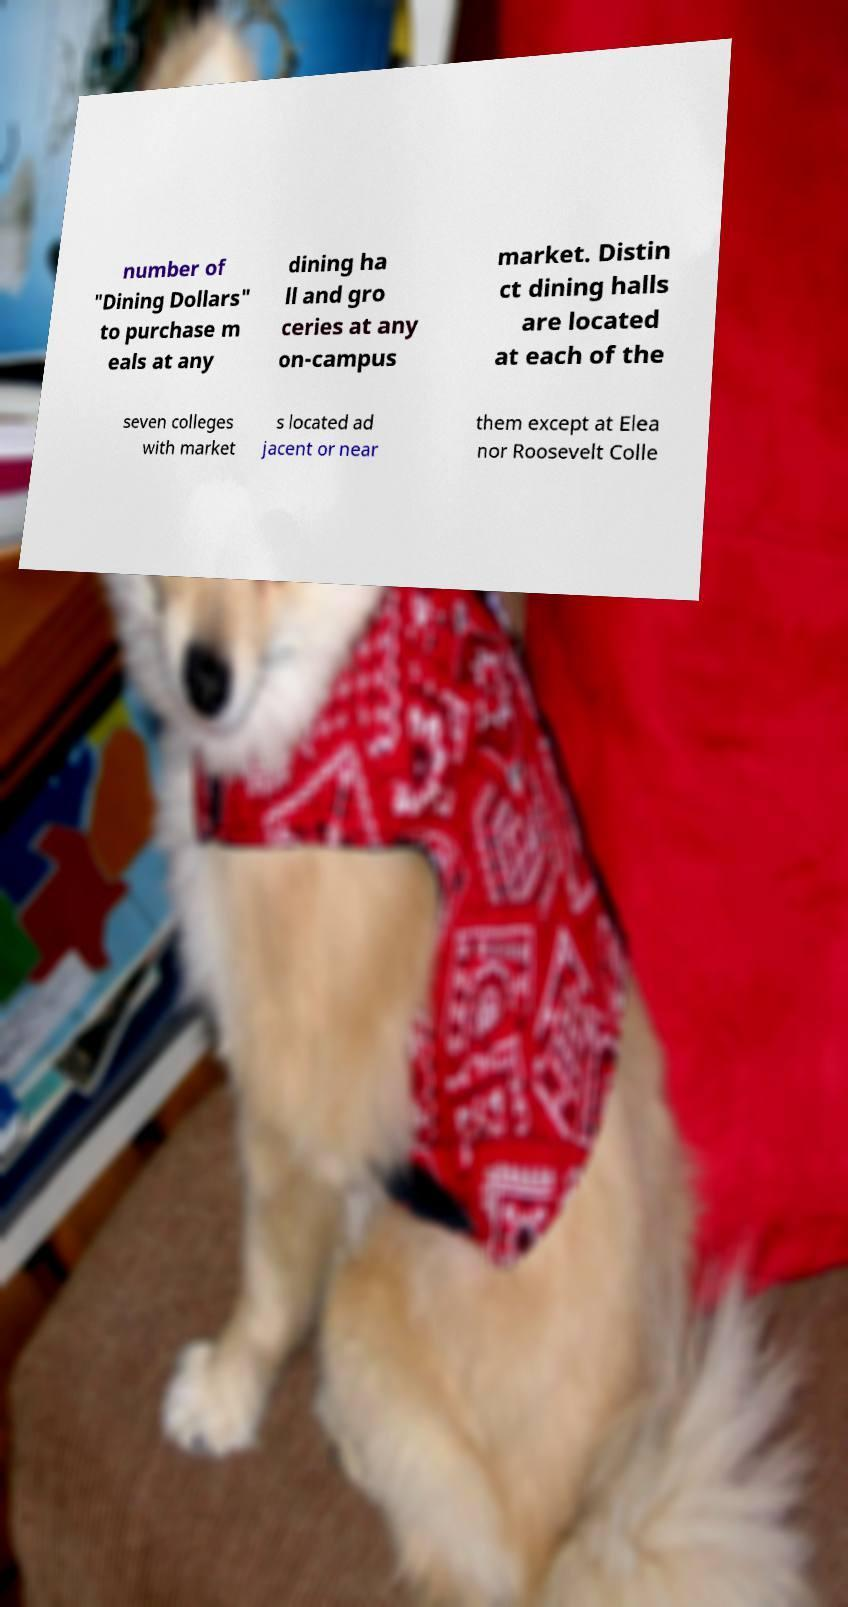I need the written content from this picture converted into text. Can you do that? number of "Dining Dollars" to purchase m eals at any dining ha ll and gro ceries at any on-campus market. Distin ct dining halls are located at each of the seven colleges with market s located ad jacent or near them except at Elea nor Roosevelt Colle 